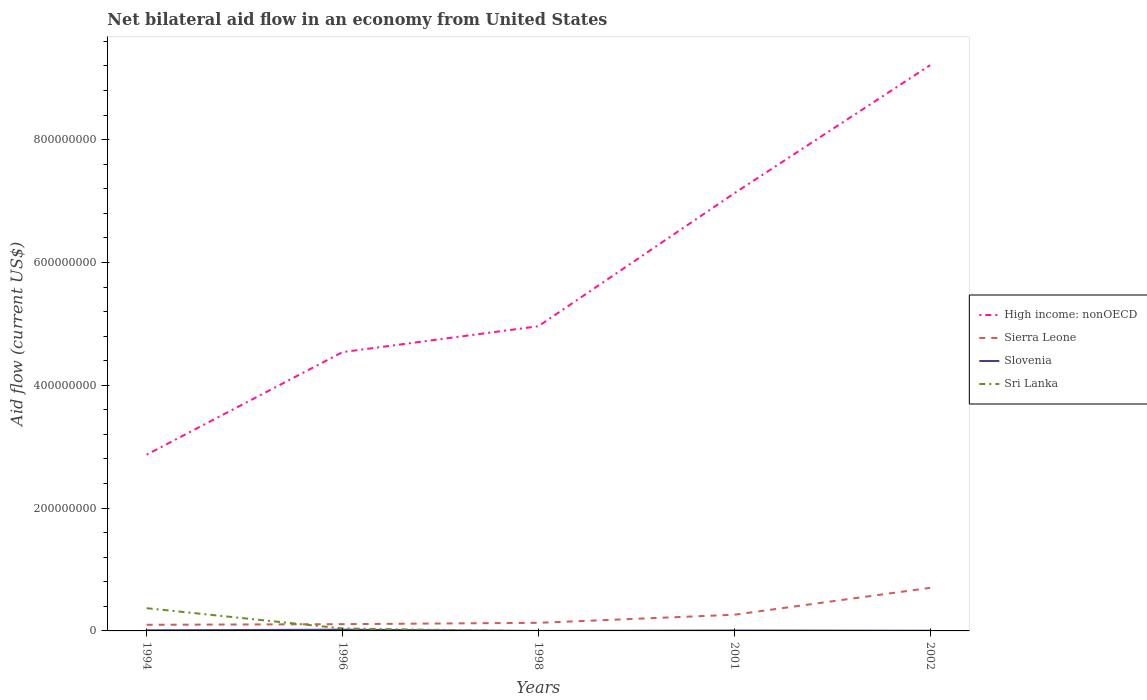Across all years, what is the maximum net bilateral aid flow in Sierra Leone?
Give a very brief answer. 1.00e+07. What is the total net bilateral aid flow in Slovenia in the graph?
Your answer should be compact. 3.40e+05. What is the difference between the highest and the second highest net bilateral aid flow in High income: nonOECD?
Keep it short and to the point. 6.34e+08. How many lines are there?
Your response must be concise. 4. How many years are there in the graph?
Keep it short and to the point. 5. Does the graph contain any zero values?
Ensure brevity in your answer.  Yes. Where does the legend appear in the graph?
Keep it short and to the point. Center right. How are the legend labels stacked?
Your response must be concise. Vertical. What is the title of the graph?
Your response must be concise. Net bilateral aid flow in an economy from United States. What is the label or title of the Y-axis?
Ensure brevity in your answer.  Aid flow (current US$). What is the Aid flow (current US$) of High income: nonOECD in 1994?
Keep it short and to the point. 2.87e+08. What is the Aid flow (current US$) of Sierra Leone in 1994?
Your response must be concise. 1.00e+07. What is the Aid flow (current US$) of Sri Lanka in 1994?
Your answer should be compact. 3.70e+07. What is the Aid flow (current US$) in High income: nonOECD in 1996?
Provide a short and direct response. 4.54e+08. What is the Aid flow (current US$) in Sierra Leone in 1996?
Offer a terse response. 1.10e+07. What is the Aid flow (current US$) of Slovenia in 1996?
Offer a terse response. 2.00e+06. What is the Aid flow (current US$) of Sri Lanka in 1996?
Ensure brevity in your answer.  4.00e+06. What is the Aid flow (current US$) of High income: nonOECD in 1998?
Your response must be concise. 4.96e+08. What is the Aid flow (current US$) in Sierra Leone in 1998?
Your answer should be very brief. 1.32e+07. What is the Aid flow (current US$) in High income: nonOECD in 2001?
Give a very brief answer. 7.13e+08. What is the Aid flow (current US$) in Sierra Leone in 2001?
Your answer should be very brief. 2.64e+07. What is the Aid flow (current US$) in High income: nonOECD in 2002?
Offer a terse response. 9.21e+08. What is the Aid flow (current US$) of Sierra Leone in 2002?
Offer a terse response. 7.01e+07. What is the Aid flow (current US$) in Sri Lanka in 2002?
Offer a very short reply. 0. Across all years, what is the maximum Aid flow (current US$) of High income: nonOECD?
Ensure brevity in your answer.  9.21e+08. Across all years, what is the maximum Aid flow (current US$) in Sierra Leone?
Offer a very short reply. 7.01e+07. Across all years, what is the maximum Aid flow (current US$) in Sri Lanka?
Provide a short and direct response. 3.70e+07. Across all years, what is the minimum Aid flow (current US$) in High income: nonOECD?
Provide a short and direct response. 2.87e+08. Across all years, what is the minimum Aid flow (current US$) of Slovenia?
Make the answer very short. 10000. Across all years, what is the minimum Aid flow (current US$) in Sri Lanka?
Offer a terse response. 0. What is the total Aid flow (current US$) of High income: nonOECD in the graph?
Give a very brief answer. 2.87e+09. What is the total Aid flow (current US$) in Sierra Leone in the graph?
Provide a succinct answer. 1.31e+08. What is the total Aid flow (current US$) of Slovenia in the graph?
Offer a very short reply. 3.97e+06. What is the total Aid flow (current US$) of Sri Lanka in the graph?
Your answer should be very brief. 4.10e+07. What is the difference between the Aid flow (current US$) of High income: nonOECD in 1994 and that in 1996?
Your answer should be very brief. -1.67e+08. What is the difference between the Aid flow (current US$) in Slovenia in 1994 and that in 1996?
Your answer should be compact. -1.00e+06. What is the difference between the Aid flow (current US$) in Sri Lanka in 1994 and that in 1996?
Provide a short and direct response. 3.30e+07. What is the difference between the Aid flow (current US$) in High income: nonOECD in 1994 and that in 1998?
Give a very brief answer. -2.09e+08. What is the difference between the Aid flow (current US$) of Sierra Leone in 1994 and that in 1998?
Make the answer very short. -3.19e+06. What is the difference between the Aid flow (current US$) in Slovenia in 1994 and that in 1998?
Give a very brief answer. 9.90e+05. What is the difference between the Aid flow (current US$) of High income: nonOECD in 1994 and that in 2001?
Offer a terse response. -4.26e+08. What is the difference between the Aid flow (current US$) of Sierra Leone in 1994 and that in 2001?
Your response must be concise. -1.64e+07. What is the difference between the Aid flow (current US$) of High income: nonOECD in 1994 and that in 2002?
Offer a terse response. -6.34e+08. What is the difference between the Aid flow (current US$) of Sierra Leone in 1994 and that in 2002?
Keep it short and to the point. -6.01e+07. What is the difference between the Aid flow (current US$) of High income: nonOECD in 1996 and that in 1998?
Keep it short and to the point. -4.22e+07. What is the difference between the Aid flow (current US$) of Sierra Leone in 1996 and that in 1998?
Your answer should be very brief. -2.19e+06. What is the difference between the Aid flow (current US$) in Slovenia in 1996 and that in 1998?
Offer a terse response. 1.99e+06. What is the difference between the Aid flow (current US$) of High income: nonOECD in 1996 and that in 2001?
Make the answer very short. -2.59e+08. What is the difference between the Aid flow (current US$) in Sierra Leone in 1996 and that in 2001?
Your answer should be compact. -1.54e+07. What is the difference between the Aid flow (current US$) of Slovenia in 1996 and that in 2001?
Your answer should be compact. 1.34e+06. What is the difference between the Aid flow (current US$) in High income: nonOECD in 1996 and that in 2002?
Your response must be concise. -4.67e+08. What is the difference between the Aid flow (current US$) in Sierra Leone in 1996 and that in 2002?
Make the answer very short. -5.91e+07. What is the difference between the Aid flow (current US$) in Slovenia in 1996 and that in 2002?
Give a very brief answer. 1.70e+06. What is the difference between the Aid flow (current US$) of High income: nonOECD in 1998 and that in 2001?
Your response must be concise. -2.16e+08. What is the difference between the Aid flow (current US$) of Sierra Leone in 1998 and that in 2001?
Offer a terse response. -1.32e+07. What is the difference between the Aid flow (current US$) in Slovenia in 1998 and that in 2001?
Your answer should be very brief. -6.50e+05. What is the difference between the Aid flow (current US$) of High income: nonOECD in 1998 and that in 2002?
Your answer should be compact. -4.25e+08. What is the difference between the Aid flow (current US$) in Sierra Leone in 1998 and that in 2002?
Ensure brevity in your answer.  -5.69e+07. What is the difference between the Aid flow (current US$) of Slovenia in 1998 and that in 2002?
Your response must be concise. -2.90e+05. What is the difference between the Aid flow (current US$) in High income: nonOECD in 2001 and that in 2002?
Your response must be concise. -2.09e+08. What is the difference between the Aid flow (current US$) in Sierra Leone in 2001 and that in 2002?
Keep it short and to the point. -4.38e+07. What is the difference between the Aid flow (current US$) of High income: nonOECD in 1994 and the Aid flow (current US$) of Sierra Leone in 1996?
Your answer should be compact. 2.76e+08. What is the difference between the Aid flow (current US$) of High income: nonOECD in 1994 and the Aid flow (current US$) of Slovenia in 1996?
Keep it short and to the point. 2.85e+08. What is the difference between the Aid flow (current US$) in High income: nonOECD in 1994 and the Aid flow (current US$) in Sri Lanka in 1996?
Provide a succinct answer. 2.83e+08. What is the difference between the Aid flow (current US$) in Sierra Leone in 1994 and the Aid flow (current US$) in Slovenia in 1996?
Give a very brief answer. 8.00e+06. What is the difference between the Aid flow (current US$) of High income: nonOECD in 1994 and the Aid flow (current US$) of Sierra Leone in 1998?
Provide a short and direct response. 2.74e+08. What is the difference between the Aid flow (current US$) of High income: nonOECD in 1994 and the Aid flow (current US$) of Slovenia in 1998?
Keep it short and to the point. 2.87e+08. What is the difference between the Aid flow (current US$) of Sierra Leone in 1994 and the Aid flow (current US$) of Slovenia in 1998?
Provide a short and direct response. 9.99e+06. What is the difference between the Aid flow (current US$) of High income: nonOECD in 1994 and the Aid flow (current US$) of Sierra Leone in 2001?
Provide a short and direct response. 2.61e+08. What is the difference between the Aid flow (current US$) of High income: nonOECD in 1994 and the Aid flow (current US$) of Slovenia in 2001?
Offer a terse response. 2.86e+08. What is the difference between the Aid flow (current US$) in Sierra Leone in 1994 and the Aid flow (current US$) in Slovenia in 2001?
Your answer should be compact. 9.34e+06. What is the difference between the Aid flow (current US$) in High income: nonOECD in 1994 and the Aid flow (current US$) in Sierra Leone in 2002?
Your answer should be compact. 2.17e+08. What is the difference between the Aid flow (current US$) in High income: nonOECD in 1994 and the Aid flow (current US$) in Slovenia in 2002?
Your answer should be very brief. 2.87e+08. What is the difference between the Aid flow (current US$) in Sierra Leone in 1994 and the Aid flow (current US$) in Slovenia in 2002?
Your response must be concise. 9.70e+06. What is the difference between the Aid flow (current US$) in High income: nonOECD in 1996 and the Aid flow (current US$) in Sierra Leone in 1998?
Your answer should be very brief. 4.41e+08. What is the difference between the Aid flow (current US$) in High income: nonOECD in 1996 and the Aid flow (current US$) in Slovenia in 1998?
Your response must be concise. 4.54e+08. What is the difference between the Aid flow (current US$) of Sierra Leone in 1996 and the Aid flow (current US$) of Slovenia in 1998?
Your answer should be compact. 1.10e+07. What is the difference between the Aid flow (current US$) in High income: nonOECD in 1996 and the Aid flow (current US$) in Sierra Leone in 2001?
Give a very brief answer. 4.28e+08. What is the difference between the Aid flow (current US$) in High income: nonOECD in 1996 and the Aid flow (current US$) in Slovenia in 2001?
Keep it short and to the point. 4.53e+08. What is the difference between the Aid flow (current US$) of Sierra Leone in 1996 and the Aid flow (current US$) of Slovenia in 2001?
Your response must be concise. 1.03e+07. What is the difference between the Aid flow (current US$) of High income: nonOECD in 1996 and the Aid flow (current US$) of Sierra Leone in 2002?
Give a very brief answer. 3.84e+08. What is the difference between the Aid flow (current US$) of High income: nonOECD in 1996 and the Aid flow (current US$) of Slovenia in 2002?
Provide a short and direct response. 4.54e+08. What is the difference between the Aid flow (current US$) of Sierra Leone in 1996 and the Aid flow (current US$) of Slovenia in 2002?
Your answer should be compact. 1.07e+07. What is the difference between the Aid flow (current US$) of High income: nonOECD in 1998 and the Aid flow (current US$) of Sierra Leone in 2001?
Give a very brief answer. 4.70e+08. What is the difference between the Aid flow (current US$) in High income: nonOECD in 1998 and the Aid flow (current US$) in Slovenia in 2001?
Offer a terse response. 4.95e+08. What is the difference between the Aid flow (current US$) of Sierra Leone in 1998 and the Aid flow (current US$) of Slovenia in 2001?
Provide a short and direct response. 1.25e+07. What is the difference between the Aid flow (current US$) of High income: nonOECD in 1998 and the Aid flow (current US$) of Sierra Leone in 2002?
Your response must be concise. 4.26e+08. What is the difference between the Aid flow (current US$) in High income: nonOECD in 1998 and the Aid flow (current US$) in Slovenia in 2002?
Keep it short and to the point. 4.96e+08. What is the difference between the Aid flow (current US$) of Sierra Leone in 1998 and the Aid flow (current US$) of Slovenia in 2002?
Provide a short and direct response. 1.29e+07. What is the difference between the Aid flow (current US$) of High income: nonOECD in 2001 and the Aid flow (current US$) of Sierra Leone in 2002?
Offer a very short reply. 6.42e+08. What is the difference between the Aid flow (current US$) of High income: nonOECD in 2001 and the Aid flow (current US$) of Slovenia in 2002?
Make the answer very short. 7.12e+08. What is the difference between the Aid flow (current US$) of Sierra Leone in 2001 and the Aid flow (current US$) of Slovenia in 2002?
Offer a terse response. 2.61e+07. What is the average Aid flow (current US$) of High income: nonOECD per year?
Your response must be concise. 5.74e+08. What is the average Aid flow (current US$) in Sierra Leone per year?
Your answer should be very brief. 2.61e+07. What is the average Aid flow (current US$) in Slovenia per year?
Give a very brief answer. 7.94e+05. What is the average Aid flow (current US$) of Sri Lanka per year?
Ensure brevity in your answer.  8.20e+06. In the year 1994, what is the difference between the Aid flow (current US$) in High income: nonOECD and Aid flow (current US$) in Sierra Leone?
Make the answer very short. 2.77e+08. In the year 1994, what is the difference between the Aid flow (current US$) of High income: nonOECD and Aid flow (current US$) of Slovenia?
Give a very brief answer. 2.86e+08. In the year 1994, what is the difference between the Aid flow (current US$) of High income: nonOECD and Aid flow (current US$) of Sri Lanka?
Offer a terse response. 2.50e+08. In the year 1994, what is the difference between the Aid flow (current US$) of Sierra Leone and Aid flow (current US$) of Slovenia?
Ensure brevity in your answer.  9.00e+06. In the year 1994, what is the difference between the Aid flow (current US$) of Sierra Leone and Aid flow (current US$) of Sri Lanka?
Keep it short and to the point. -2.70e+07. In the year 1994, what is the difference between the Aid flow (current US$) of Slovenia and Aid flow (current US$) of Sri Lanka?
Offer a terse response. -3.60e+07. In the year 1996, what is the difference between the Aid flow (current US$) in High income: nonOECD and Aid flow (current US$) in Sierra Leone?
Your answer should be very brief. 4.43e+08. In the year 1996, what is the difference between the Aid flow (current US$) of High income: nonOECD and Aid flow (current US$) of Slovenia?
Your answer should be compact. 4.52e+08. In the year 1996, what is the difference between the Aid flow (current US$) of High income: nonOECD and Aid flow (current US$) of Sri Lanka?
Your answer should be very brief. 4.50e+08. In the year 1996, what is the difference between the Aid flow (current US$) of Sierra Leone and Aid flow (current US$) of Slovenia?
Your answer should be very brief. 9.00e+06. In the year 1996, what is the difference between the Aid flow (current US$) of Slovenia and Aid flow (current US$) of Sri Lanka?
Offer a terse response. -2.00e+06. In the year 1998, what is the difference between the Aid flow (current US$) in High income: nonOECD and Aid flow (current US$) in Sierra Leone?
Your response must be concise. 4.83e+08. In the year 1998, what is the difference between the Aid flow (current US$) in High income: nonOECD and Aid flow (current US$) in Slovenia?
Keep it short and to the point. 4.96e+08. In the year 1998, what is the difference between the Aid flow (current US$) of Sierra Leone and Aid flow (current US$) of Slovenia?
Ensure brevity in your answer.  1.32e+07. In the year 2001, what is the difference between the Aid flow (current US$) of High income: nonOECD and Aid flow (current US$) of Sierra Leone?
Your answer should be very brief. 6.86e+08. In the year 2001, what is the difference between the Aid flow (current US$) of High income: nonOECD and Aid flow (current US$) of Slovenia?
Make the answer very short. 7.12e+08. In the year 2001, what is the difference between the Aid flow (current US$) of Sierra Leone and Aid flow (current US$) of Slovenia?
Your response must be concise. 2.57e+07. In the year 2002, what is the difference between the Aid flow (current US$) in High income: nonOECD and Aid flow (current US$) in Sierra Leone?
Offer a very short reply. 8.51e+08. In the year 2002, what is the difference between the Aid flow (current US$) in High income: nonOECD and Aid flow (current US$) in Slovenia?
Give a very brief answer. 9.21e+08. In the year 2002, what is the difference between the Aid flow (current US$) of Sierra Leone and Aid flow (current US$) of Slovenia?
Keep it short and to the point. 6.98e+07. What is the ratio of the Aid flow (current US$) of High income: nonOECD in 1994 to that in 1996?
Your answer should be very brief. 0.63. What is the ratio of the Aid flow (current US$) of Slovenia in 1994 to that in 1996?
Give a very brief answer. 0.5. What is the ratio of the Aid flow (current US$) of Sri Lanka in 1994 to that in 1996?
Ensure brevity in your answer.  9.25. What is the ratio of the Aid flow (current US$) of High income: nonOECD in 1994 to that in 1998?
Your response must be concise. 0.58. What is the ratio of the Aid flow (current US$) in Sierra Leone in 1994 to that in 1998?
Your answer should be compact. 0.76. What is the ratio of the Aid flow (current US$) of High income: nonOECD in 1994 to that in 2001?
Provide a succinct answer. 0.4. What is the ratio of the Aid flow (current US$) of Sierra Leone in 1994 to that in 2001?
Keep it short and to the point. 0.38. What is the ratio of the Aid flow (current US$) in Slovenia in 1994 to that in 2001?
Your answer should be very brief. 1.52. What is the ratio of the Aid flow (current US$) of High income: nonOECD in 1994 to that in 2002?
Offer a terse response. 0.31. What is the ratio of the Aid flow (current US$) of Sierra Leone in 1994 to that in 2002?
Your answer should be very brief. 0.14. What is the ratio of the Aid flow (current US$) in High income: nonOECD in 1996 to that in 1998?
Make the answer very short. 0.92. What is the ratio of the Aid flow (current US$) in Sierra Leone in 1996 to that in 1998?
Your response must be concise. 0.83. What is the ratio of the Aid flow (current US$) of High income: nonOECD in 1996 to that in 2001?
Keep it short and to the point. 0.64. What is the ratio of the Aid flow (current US$) in Sierra Leone in 1996 to that in 2001?
Ensure brevity in your answer.  0.42. What is the ratio of the Aid flow (current US$) of Slovenia in 1996 to that in 2001?
Provide a short and direct response. 3.03. What is the ratio of the Aid flow (current US$) in High income: nonOECD in 1996 to that in 2002?
Your answer should be compact. 0.49. What is the ratio of the Aid flow (current US$) in Sierra Leone in 1996 to that in 2002?
Keep it short and to the point. 0.16. What is the ratio of the Aid flow (current US$) in High income: nonOECD in 1998 to that in 2001?
Keep it short and to the point. 0.7. What is the ratio of the Aid flow (current US$) of Sierra Leone in 1998 to that in 2001?
Keep it short and to the point. 0.5. What is the ratio of the Aid flow (current US$) in Slovenia in 1998 to that in 2001?
Provide a short and direct response. 0.02. What is the ratio of the Aid flow (current US$) of High income: nonOECD in 1998 to that in 2002?
Provide a succinct answer. 0.54. What is the ratio of the Aid flow (current US$) of Sierra Leone in 1998 to that in 2002?
Provide a succinct answer. 0.19. What is the ratio of the Aid flow (current US$) of Slovenia in 1998 to that in 2002?
Offer a very short reply. 0.03. What is the ratio of the Aid flow (current US$) of High income: nonOECD in 2001 to that in 2002?
Your answer should be very brief. 0.77. What is the ratio of the Aid flow (current US$) in Sierra Leone in 2001 to that in 2002?
Provide a short and direct response. 0.38. What is the ratio of the Aid flow (current US$) of Slovenia in 2001 to that in 2002?
Your answer should be compact. 2.2. What is the difference between the highest and the second highest Aid flow (current US$) of High income: nonOECD?
Your answer should be very brief. 2.09e+08. What is the difference between the highest and the second highest Aid flow (current US$) in Sierra Leone?
Your answer should be compact. 4.38e+07. What is the difference between the highest and the lowest Aid flow (current US$) in High income: nonOECD?
Keep it short and to the point. 6.34e+08. What is the difference between the highest and the lowest Aid flow (current US$) of Sierra Leone?
Ensure brevity in your answer.  6.01e+07. What is the difference between the highest and the lowest Aid flow (current US$) of Slovenia?
Offer a very short reply. 1.99e+06. What is the difference between the highest and the lowest Aid flow (current US$) in Sri Lanka?
Give a very brief answer. 3.70e+07. 